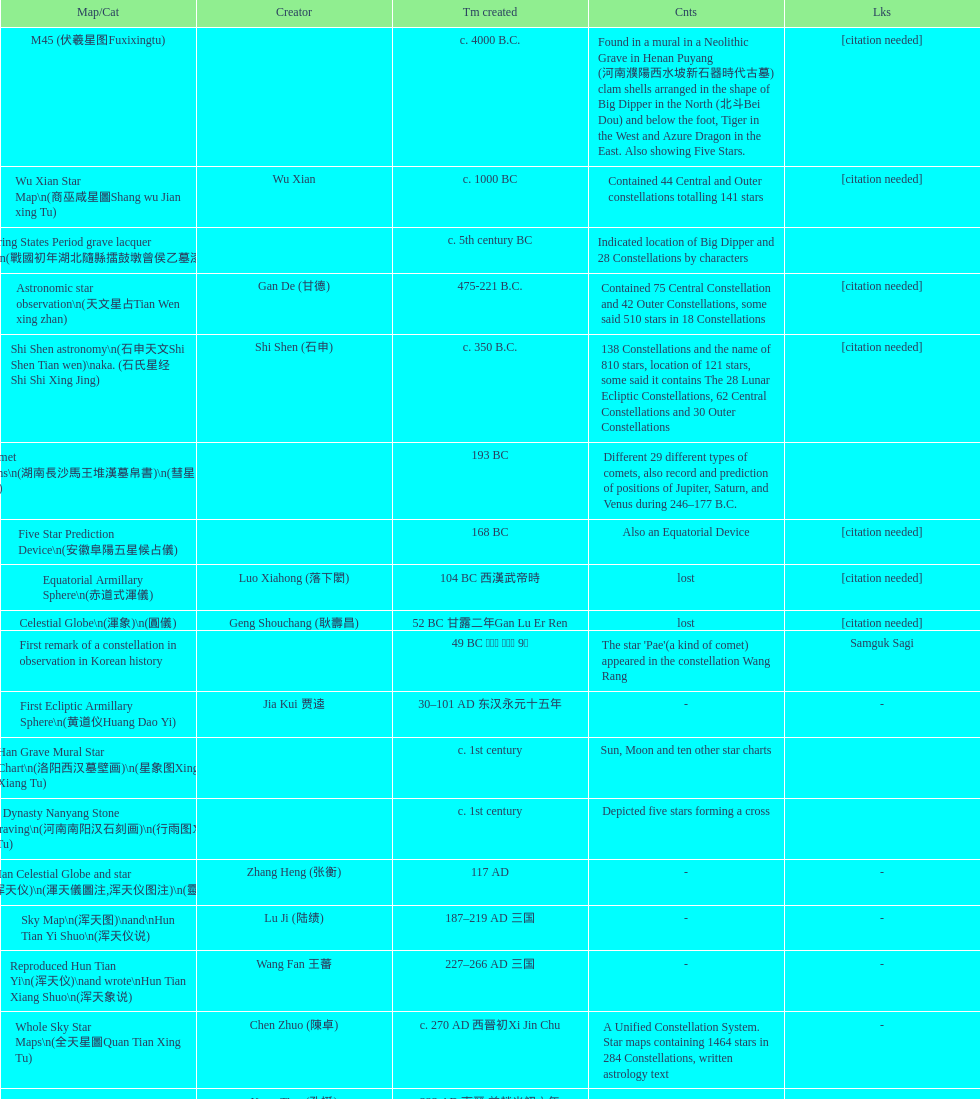Which star map was developed first, celestial sphere or the han tomb mural star diagram? Celestial Globe. 